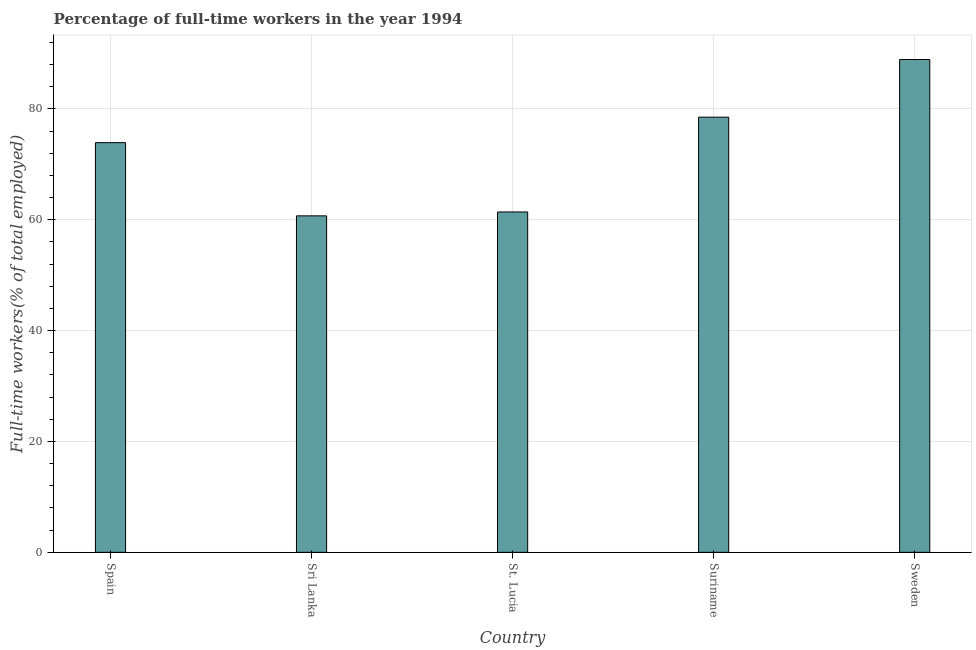What is the title of the graph?
Your response must be concise. Percentage of full-time workers in the year 1994. What is the label or title of the X-axis?
Offer a very short reply. Country. What is the label or title of the Y-axis?
Your answer should be very brief. Full-time workers(% of total employed). What is the percentage of full-time workers in Suriname?
Provide a succinct answer. 78.5. Across all countries, what is the maximum percentage of full-time workers?
Give a very brief answer. 88.9. Across all countries, what is the minimum percentage of full-time workers?
Your response must be concise. 60.7. In which country was the percentage of full-time workers maximum?
Your response must be concise. Sweden. In which country was the percentage of full-time workers minimum?
Provide a short and direct response. Sri Lanka. What is the sum of the percentage of full-time workers?
Make the answer very short. 363.4. What is the difference between the percentage of full-time workers in Spain and Sri Lanka?
Your answer should be compact. 13.2. What is the average percentage of full-time workers per country?
Your response must be concise. 72.68. What is the median percentage of full-time workers?
Keep it short and to the point. 73.9. In how many countries, is the percentage of full-time workers greater than 40 %?
Give a very brief answer. 5. What is the ratio of the percentage of full-time workers in Spain to that in Sweden?
Provide a succinct answer. 0.83. Is the percentage of full-time workers in St. Lucia less than that in Sweden?
Make the answer very short. Yes. What is the difference between the highest and the lowest percentage of full-time workers?
Give a very brief answer. 28.2. In how many countries, is the percentage of full-time workers greater than the average percentage of full-time workers taken over all countries?
Your answer should be compact. 3. How many bars are there?
Make the answer very short. 5. Are all the bars in the graph horizontal?
Offer a very short reply. No. What is the difference between two consecutive major ticks on the Y-axis?
Offer a very short reply. 20. What is the Full-time workers(% of total employed) of Spain?
Make the answer very short. 73.9. What is the Full-time workers(% of total employed) of Sri Lanka?
Give a very brief answer. 60.7. What is the Full-time workers(% of total employed) of St. Lucia?
Your answer should be compact. 61.4. What is the Full-time workers(% of total employed) of Suriname?
Ensure brevity in your answer.  78.5. What is the Full-time workers(% of total employed) in Sweden?
Offer a terse response. 88.9. What is the difference between the Full-time workers(% of total employed) in Spain and St. Lucia?
Provide a short and direct response. 12.5. What is the difference between the Full-time workers(% of total employed) in Spain and Suriname?
Your answer should be very brief. -4.6. What is the difference between the Full-time workers(% of total employed) in Sri Lanka and Suriname?
Provide a short and direct response. -17.8. What is the difference between the Full-time workers(% of total employed) in Sri Lanka and Sweden?
Your answer should be compact. -28.2. What is the difference between the Full-time workers(% of total employed) in St. Lucia and Suriname?
Make the answer very short. -17.1. What is the difference between the Full-time workers(% of total employed) in St. Lucia and Sweden?
Provide a short and direct response. -27.5. What is the difference between the Full-time workers(% of total employed) in Suriname and Sweden?
Give a very brief answer. -10.4. What is the ratio of the Full-time workers(% of total employed) in Spain to that in Sri Lanka?
Make the answer very short. 1.22. What is the ratio of the Full-time workers(% of total employed) in Spain to that in St. Lucia?
Give a very brief answer. 1.2. What is the ratio of the Full-time workers(% of total employed) in Spain to that in Suriname?
Offer a terse response. 0.94. What is the ratio of the Full-time workers(% of total employed) in Spain to that in Sweden?
Offer a terse response. 0.83. What is the ratio of the Full-time workers(% of total employed) in Sri Lanka to that in St. Lucia?
Make the answer very short. 0.99. What is the ratio of the Full-time workers(% of total employed) in Sri Lanka to that in Suriname?
Offer a terse response. 0.77. What is the ratio of the Full-time workers(% of total employed) in Sri Lanka to that in Sweden?
Give a very brief answer. 0.68. What is the ratio of the Full-time workers(% of total employed) in St. Lucia to that in Suriname?
Provide a succinct answer. 0.78. What is the ratio of the Full-time workers(% of total employed) in St. Lucia to that in Sweden?
Offer a very short reply. 0.69. What is the ratio of the Full-time workers(% of total employed) in Suriname to that in Sweden?
Offer a very short reply. 0.88. 